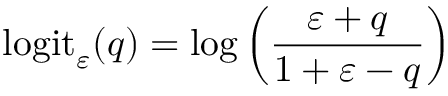<formula> <loc_0><loc_0><loc_500><loc_500>\log i t _ { \varepsilon } ( q ) = \log \left ( \frac { \varepsilon + q } { 1 + \varepsilon - q } \right )</formula> 